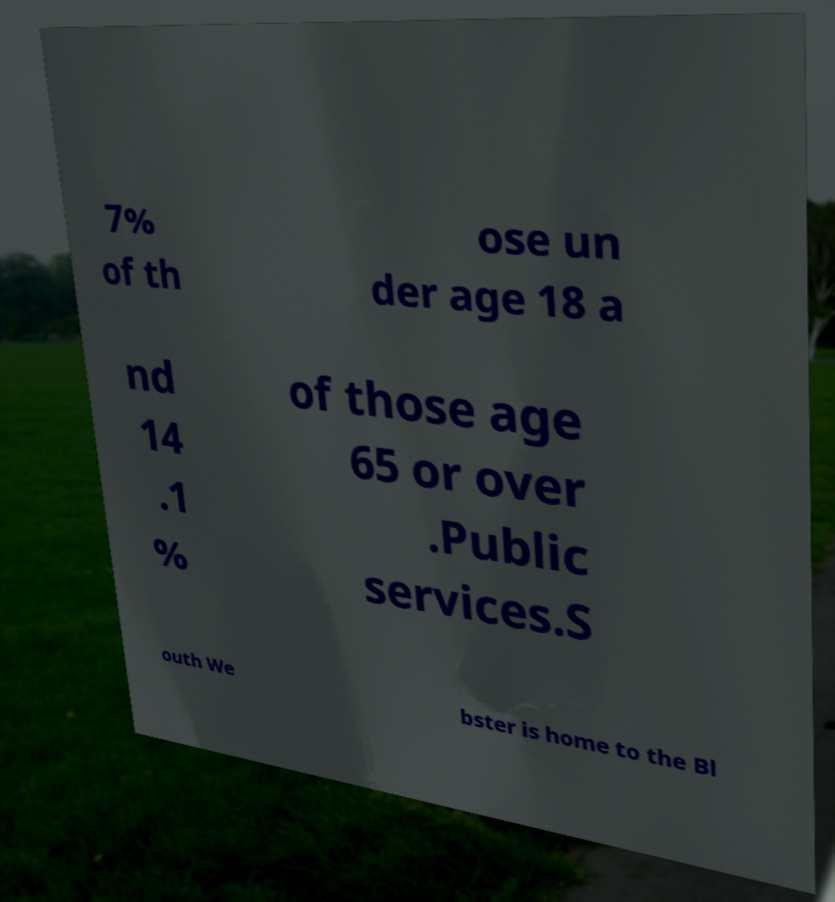I need the written content from this picture converted into text. Can you do that? 7% of th ose un der age 18 a nd 14 .1 % of those age 65 or over .Public services.S outh We bster is home to the Bl 